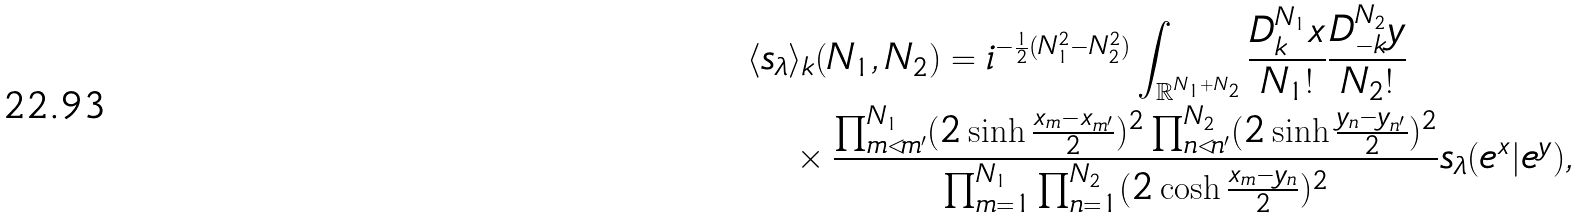<formula> <loc_0><loc_0><loc_500><loc_500>& \langle s _ { \lambda } \rangle _ { k } ( N _ { 1 } , N _ { 2 } ) = i ^ { - \frac { 1 } { 2 } ( N _ { 1 } ^ { 2 } - N _ { 2 } ^ { 2 } ) } \int _ { { \mathbb { R } } ^ { N _ { 1 } + N _ { 2 } } } \frac { D _ { k } ^ { N _ { 1 } } x } { N _ { 1 } ! } \frac { D _ { - k } ^ { N _ { 2 } } y } { N _ { 2 } ! } \\ & \quad \times \frac { \prod _ { m < m ^ { \prime } } ^ { N _ { 1 } } ( 2 \sinh \frac { x _ { m } - x _ { m ^ { \prime } } } { 2 } ) ^ { 2 } \prod _ { n < n ^ { \prime } } ^ { N _ { 2 } } ( 2 \sinh \frac { y _ { n } - y _ { n ^ { \prime } } } { 2 } ) ^ { 2 } } { \prod _ { m = 1 } ^ { N _ { 1 } } \prod _ { n = 1 } ^ { N _ { 2 } } ( 2 \cosh \frac { x _ { m } - y _ { n } } { 2 } ) ^ { 2 } } s _ { \lambda } ( e ^ { x } | e ^ { y } ) ,</formula> 